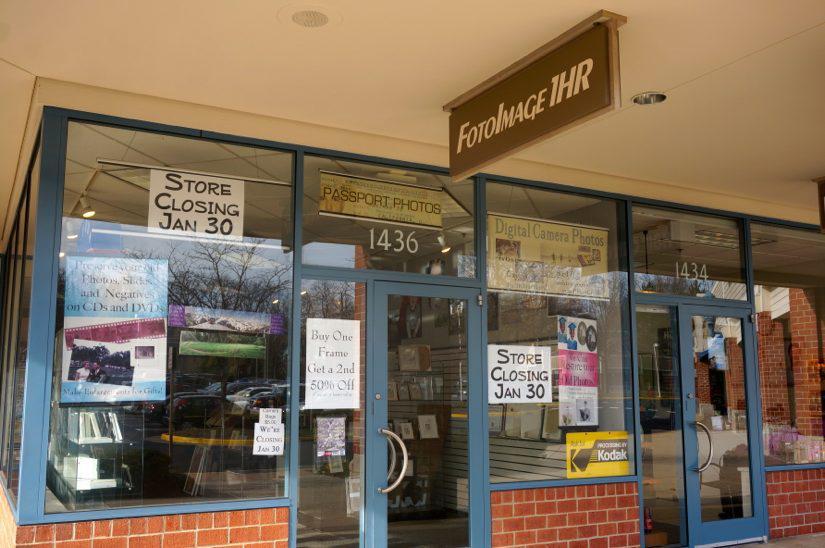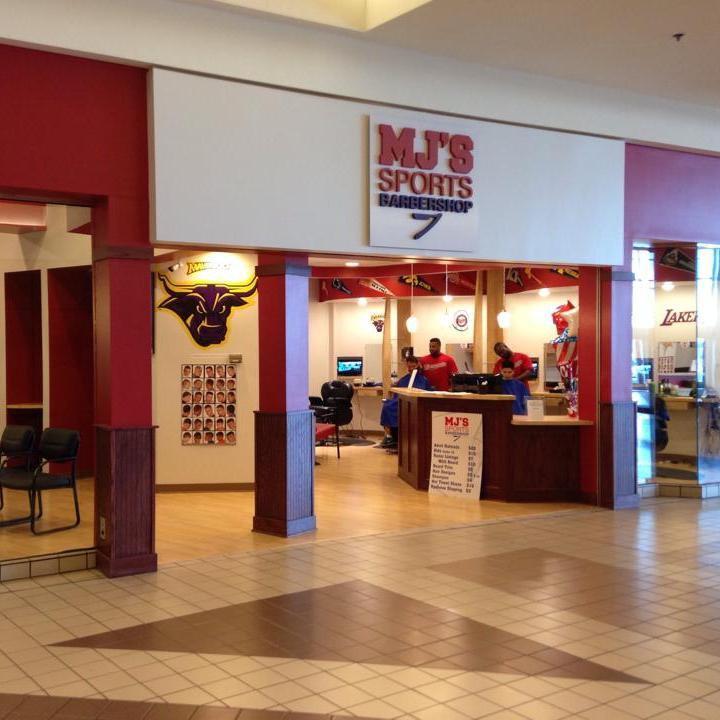The first image is the image on the left, the second image is the image on the right. Examine the images to the left and right. Is the description "There is a barber pole in the image on the right." accurate? Answer yes or no. No. 